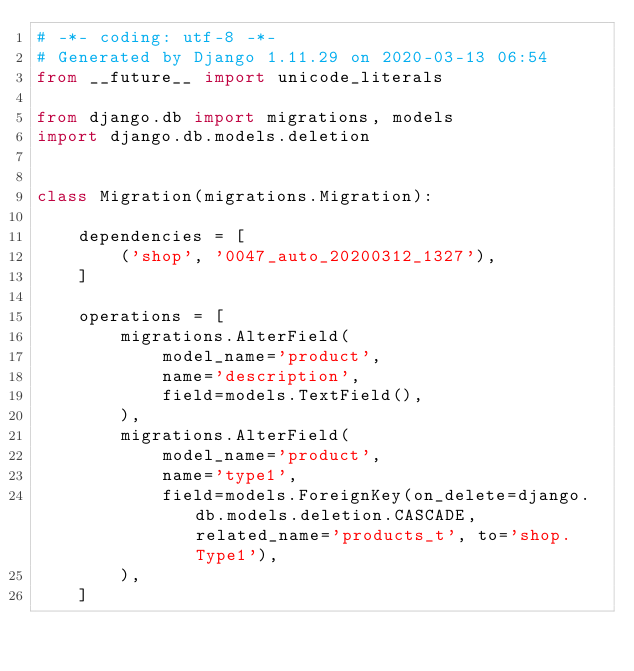<code> <loc_0><loc_0><loc_500><loc_500><_Python_># -*- coding: utf-8 -*-
# Generated by Django 1.11.29 on 2020-03-13 06:54
from __future__ import unicode_literals

from django.db import migrations, models
import django.db.models.deletion


class Migration(migrations.Migration):

    dependencies = [
        ('shop', '0047_auto_20200312_1327'),
    ]

    operations = [
        migrations.AlterField(
            model_name='product',
            name='description',
            field=models.TextField(),
        ),
        migrations.AlterField(
            model_name='product',
            name='type1',
            field=models.ForeignKey(on_delete=django.db.models.deletion.CASCADE, related_name='products_t', to='shop.Type1'),
        ),
    ]
</code> 